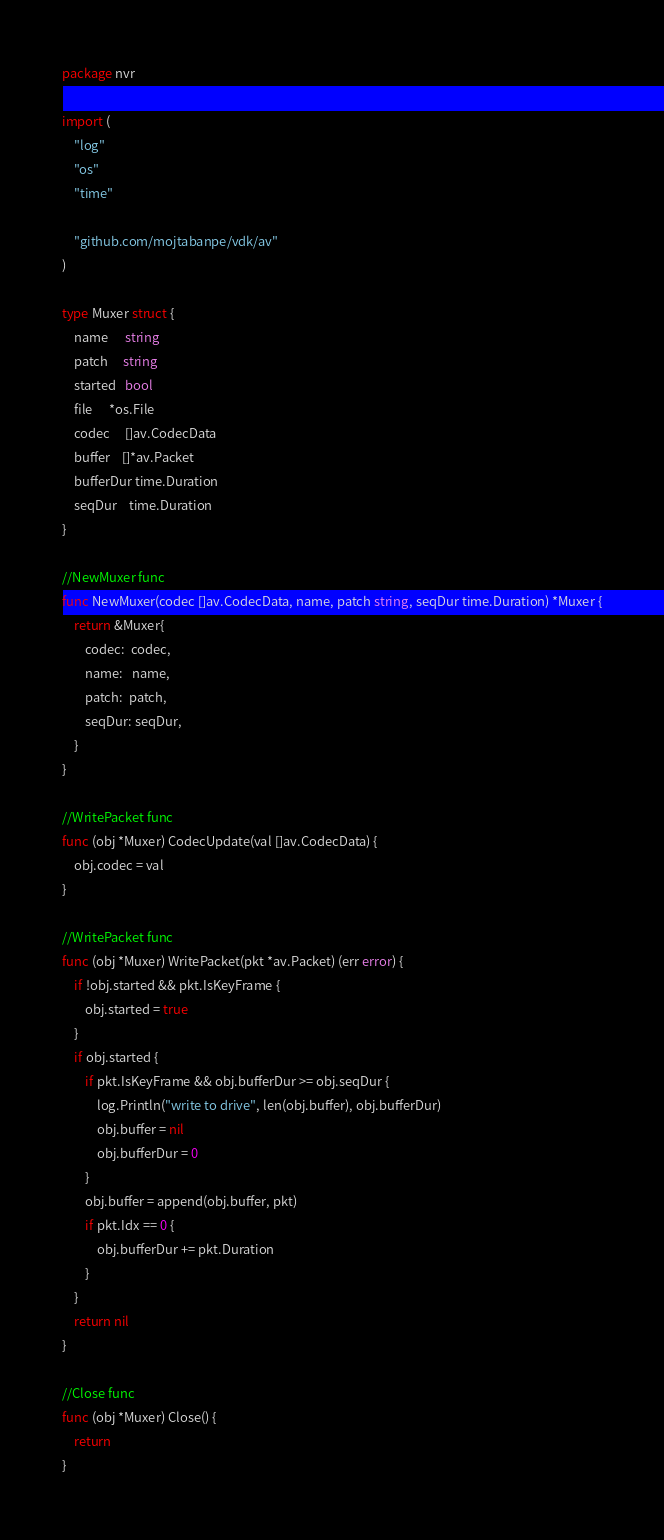<code> <loc_0><loc_0><loc_500><loc_500><_Go_>package nvr

import (
	"log"
	"os"
	"time"

	"github.com/mojtabanpe/vdk/av"
)

type Muxer struct {
	name      string
	patch     string
	started   bool
	file      *os.File
	codec     []av.CodecData
	buffer    []*av.Packet
	bufferDur time.Duration
	seqDur    time.Duration
}

//NewMuxer func
func NewMuxer(codec []av.CodecData, name, patch string, seqDur time.Duration) *Muxer {
	return &Muxer{
		codec:  codec,
		name:   name,
		patch:  patch,
		seqDur: seqDur,
	}
}

//WritePacket func
func (obj *Muxer) CodecUpdate(val []av.CodecData) {
	obj.codec = val
}

//WritePacket func
func (obj *Muxer) WritePacket(pkt *av.Packet) (err error) {
	if !obj.started && pkt.IsKeyFrame {
		obj.started = true
	}
	if obj.started {
		if pkt.IsKeyFrame && obj.bufferDur >= obj.seqDur {
			log.Println("write to drive", len(obj.buffer), obj.bufferDur)
			obj.buffer = nil
			obj.bufferDur = 0
		}
		obj.buffer = append(obj.buffer, pkt)
		if pkt.Idx == 0 {
			obj.bufferDur += pkt.Duration
		}
	}
	return nil
}

//Close func
func (obj *Muxer) Close() {
	return
}
</code> 